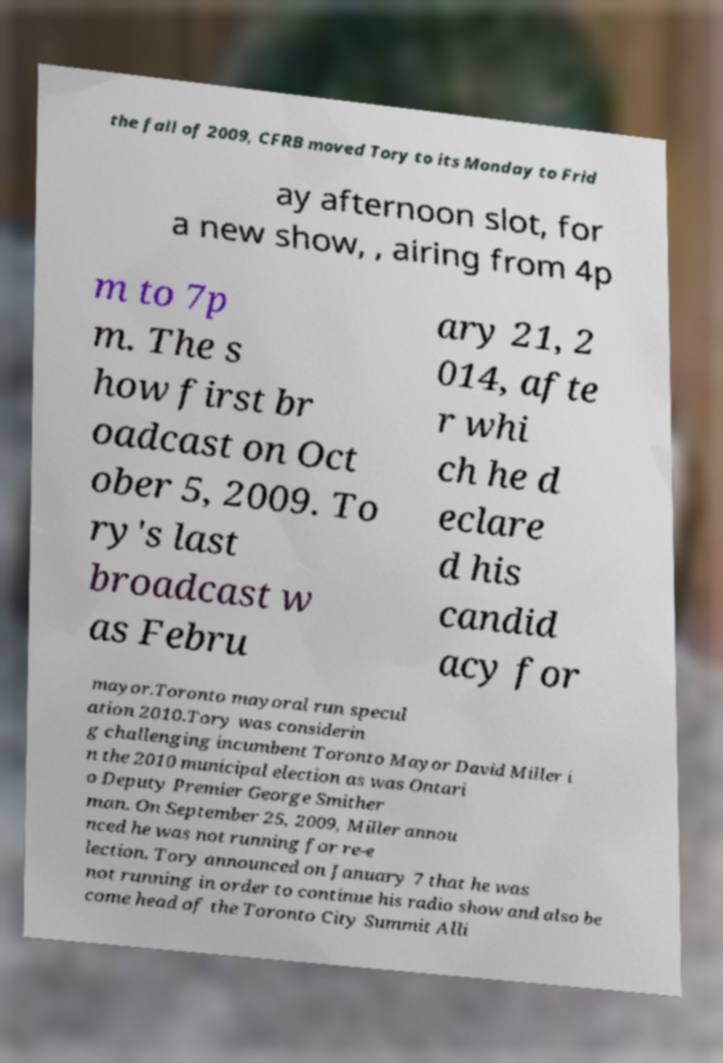For documentation purposes, I need the text within this image transcribed. Could you provide that? the fall of 2009, CFRB moved Tory to its Monday to Frid ay afternoon slot, for a new show, , airing from 4p m to 7p m. The s how first br oadcast on Oct ober 5, 2009. To ry's last broadcast w as Febru ary 21, 2 014, afte r whi ch he d eclare d his candid acy for mayor.Toronto mayoral run specul ation 2010.Tory was considerin g challenging incumbent Toronto Mayor David Miller i n the 2010 municipal election as was Ontari o Deputy Premier George Smither man. On September 25, 2009, Miller annou nced he was not running for re-e lection. Tory announced on January 7 that he was not running in order to continue his radio show and also be come head of the Toronto City Summit Alli 